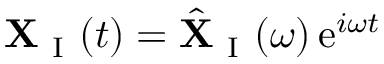Convert formula to latex. <formula><loc_0><loc_0><loc_500><loc_500>X _ { I } ( t ) = \hat { X } _ { I } ( \omega ) \, e ^ { i \omega t }</formula> 